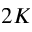Convert formula to latex. <formula><loc_0><loc_0><loc_500><loc_500>2 K</formula> 